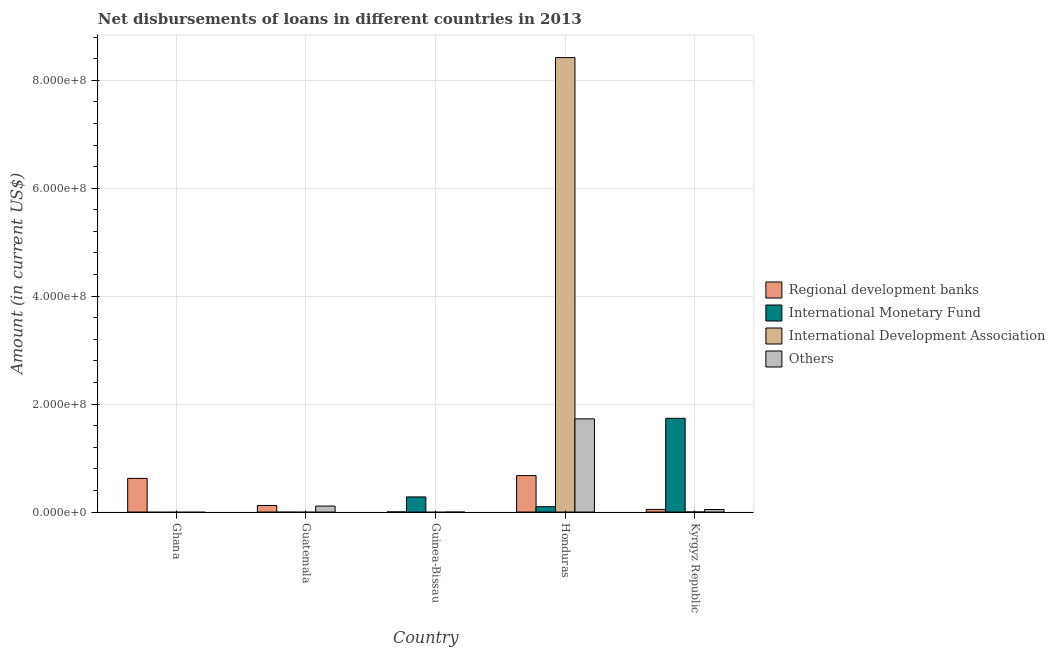Are the number of bars per tick equal to the number of legend labels?
Give a very brief answer. No. Are the number of bars on each tick of the X-axis equal?
Keep it short and to the point. No. How many bars are there on the 2nd tick from the left?
Your answer should be very brief. 2. What is the label of the 3rd group of bars from the left?
Offer a terse response. Guinea-Bissau. What is the amount of loan disimbursed by international development association in Guinea-Bissau?
Offer a very short reply. 0. Across all countries, what is the maximum amount of loan disimbursed by international monetary fund?
Make the answer very short. 1.74e+08. In which country was the amount of loan disimbursed by regional development banks maximum?
Ensure brevity in your answer.  Honduras. What is the total amount of loan disimbursed by international monetary fund in the graph?
Give a very brief answer. 2.12e+08. What is the difference between the amount of loan disimbursed by regional development banks in Guatemala and that in Kyrgyz Republic?
Provide a succinct answer. 7.32e+06. What is the difference between the amount of loan disimbursed by international development association in Kyrgyz Republic and the amount of loan disimbursed by regional development banks in Guatemala?
Make the answer very short. -1.22e+07. What is the average amount of loan disimbursed by regional development banks per country?
Offer a terse response. 2.94e+07. What is the difference between the amount of loan disimbursed by other organisations and amount of loan disimbursed by regional development banks in Honduras?
Keep it short and to the point. 1.05e+08. What is the ratio of the amount of loan disimbursed by regional development banks in Guatemala to that in Guinea-Bissau?
Provide a succinct answer. 59.67. What is the difference between the highest and the second highest amount of loan disimbursed by international monetary fund?
Make the answer very short. 1.46e+08. What is the difference between the highest and the lowest amount of loan disimbursed by other organisations?
Give a very brief answer. 1.73e+08. In how many countries, is the amount of loan disimbursed by international development association greater than the average amount of loan disimbursed by international development association taken over all countries?
Ensure brevity in your answer.  1. Is it the case that in every country, the sum of the amount of loan disimbursed by international monetary fund and amount of loan disimbursed by regional development banks is greater than the sum of amount of loan disimbursed by international development association and amount of loan disimbursed by other organisations?
Offer a terse response. No. Is it the case that in every country, the sum of the amount of loan disimbursed by regional development banks and amount of loan disimbursed by international monetary fund is greater than the amount of loan disimbursed by international development association?
Your answer should be compact. No. How many bars are there?
Ensure brevity in your answer.  12. Are all the bars in the graph horizontal?
Your answer should be very brief. No. What is the difference between two consecutive major ticks on the Y-axis?
Provide a succinct answer. 2.00e+08. Does the graph contain grids?
Your answer should be compact. Yes. What is the title of the graph?
Offer a terse response. Net disbursements of loans in different countries in 2013. What is the label or title of the X-axis?
Offer a terse response. Country. What is the label or title of the Y-axis?
Offer a terse response. Amount (in current US$). What is the Amount (in current US$) of Regional development banks in Ghana?
Your answer should be compact. 6.24e+07. What is the Amount (in current US$) of Regional development banks in Guatemala?
Provide a succinct answer. 1.22e+07. What is the Amount (in current US$) of International Monetary Fund in Guatemala?
Make the answer very short. 0. What is the Amount (in current US$) in International Development Association in Guatemala?
Keep it short and to the point. 0. What is the Amount (in current US$) in Others in Guatemala?
Your answer should be compact. 1.10e+07. What is the Amount (in current US$) of Regional development banks in Guinea-Bissau?
Offer a terse response. 2.04e+05. What is the Amount (in current US$) in International Monetary Fund in Guinea-Bissau?
Make the answer very short. 2.80e+07. What is the Amount (in current US$) of Others in Guinea-Bissau?
Offer a terse response. 0. What is the Amount (in current US$) in Regional development banks in Honduras?
Give a very brief answer. 6.75e+07. What is the Amount (in current US$) of International Monetary Fund in Honduras?
Give a very brief answer. 9.93e+06. What is the Amount (in current US$) of International Development Association in Honduras?
Make the answer very short. 8.42e+08. What is the Amount (in current US$) in Others in Honduras?
Your answer should be very brief. 1.73e+08. What is the Amount (in current US$) of Regional development banks in Kyrgyz Republic?
Offer a very short reply. 4.85e+06. What is the Amount (in current US$) of International Monetary Fund in Kyrgyz Republic?
Offer a very short reply. 1.74e+08. What is the Amount (in current US$) of Others in Kyrgyz Republic?
Ensure brevity in your answer.  4.70e+06. Across all countries, what is the maximum Amount (in current US$) of Regional development banks?
Your answer should be compact. 6.75e+07. Across all countries, what is the maximum Amount (in current US$) in International Monetary Fund?
Keep it short and to the point. 1.74e+08. Across all countries, what is the maximum Amount (in current US$) in International Development Association?
Your answer should be very brief. 8.42e+08. Across all countries, what is the maximum Amount (in current US$) in Others?
Ensure brevity in your answer.  1.73e+08. Across all countries, what is the minimum Amount (in current US$) of Regional development banks?
Offer a very short reply. 2.04e+05. Across all countries, what is the minimum Amount (in current US$) of International Monetary Fund?
Your response must be concise. 0. Across all countries, what is the minimum Amount (in current US$) of Others?
Your answer should be compact. 0. What is the total Amount (in current US$) of Regional development banks in the graph?
Make the answer very short. 1.47e+08. What is the total Amount (in current US$) in International Monetary Fund in the graph?
Keep it short and to the point. 2.12e+08. What is the total Amount (in current US$) of International Development Association in the graph?
Offer a terse response. 8.42e+08. What is the total Amount (in current US$) of Others in the graph?
Keep it short and to the point. 1.88e+08. What is the difference between the Amount (in current US$) in Regional development banks in Ghana and that in Guatemala?
Make the answer very short. 5.02e+07. What is the difference between the Amount (in current US$) in Regional development banks in Ghana and that in Guinea-Bissau?
Provide a succinct answer. 6.22e+07. What is the difference between the Amount (in current US$) in Regional development banks in Ghana and that in Honduras?
Your response must be concise. -5.11e+06. What is the difference between the Amount (in current US$) of Regional development banks in Ghana and that in Kyrgyz Republic?
Provide a succinct answer. 5.75e+07. What is the difference between the Amount (in current US$) of Regional development banks in Guatemala and that in Guinea-Bissau?
Provide a succinct answer. 1.20e+07. What is the difference between the Amount (in current US$) in Regional development banks in Guatemala and that in Honduras?
Offer a very short reply. -5.53e+07. What is the difference between the Amount (in current US$) of Others in Guatemala and that in Honduras?
Your response must be concise. -1.62e+08. What is the difference between the Amount (in current US$) in Regional development banks in Guatemala and that in Kyrgyz Republic?
Offer a terse response. 7.32e+06. What is the difference between the Amount (in current US$) in Others in Guatemala and that in Kyrgyz Republic?
Make the answer very short. 6.34e+06. What is the difference between the Amount (in current US$) in Regional development banks in Guinea-Bissau and that in Honduras?
Provide a short and direct response. -6.73e+07. What is the difference between the Amount (in current US$) of International Monetary Fund in Guinea-Bissau and that in Honduras?
Provide a short and direct response. 1.81e+07. What is the difference between the Amount (in current US$) in Regional development banks in Guinea-Bissau and that in Kyrgyz Republic?
Offer a terse response. -4.64e+06. What is the difference between the Amount (in current US$) of International Monetary Fund in Guinea-Bissau and that in Kyrgyz Republic?
Provide a short and direct response. -1.46e+08. What is the difference between the Amount (in current US$) in Regional development banks in Honduras and that in Kyrgyz Republic?
Make the answer very short. 6.26e+07. What is the difference between the Amount (in current US$) of International Monetary Fund in Honduras and that in Kyrgyz Republic?
Give a very brief answer. -1.64e+08. What is the difference between the Amount (in current US$) in Others in Honduras and that in Kyrgyz Republic?
Your answer should be compact. 1.68e+08. What is the difference between the Amount (in current US$) in Regional development banks in Ghana and the Amount (in current US$) in Others in Guatemala?
Your response must be concise. 5.13e+07. What is the difference between the Amount (in current US$) in Regional development banks in Ghana and the Amount (in current US$) in International Monetary Fund in Guinea-Bissau?
Your response must be concise. 3.44e+07. What is the difference between the Amount (in current US$) in Regional development banks in Ghana and the Amount (in current US$) in International Monetary Fund in Honduras?
Your answer should be very brief. 5.25e+07. What is the difference between the Amount (in current US$) in Regional development banks in Ghana and the Amount (in current US$) in International Development Association in Honduras?
Give a very brief answer. -7.80e+08. What is the difference between the Amount (in current US$) of Regional development banks in Ghana and the Amount (in current US$) of Others in Honduras?
Give a very brief answer. -1.10e+08. What is the difference between the Amount (in current US$) of Regional development banks in Ghana and the Amount (in current US$) of International Monetary Fund in Kyrgyz Republic?
Your response must be concise. -1.11e+08. What is the difference between the Amount (in current US$) in Regional development banks in Ghana and the Amount (in current US$) in Others in Kyrgyz Republic?
Make the answer very short. 5.77e+07. What is the difference between the Amount (in current US$) of Regional development banks in Guatemala and the Amount (in current US$) of International Monetary Fund in Guinea-Bissau?
Offer a very short reply. -1.58e+07. What is the difference between the Amount (in current US$) of Regional development banks in Guatemala and the Amount (in current US$) of International Monetary Fund in Honduras?
Offer a terse response. 2.24e+06. What is the difference between the Amount (in current US$) of Regional development banks in Guatemala and the Amount (in current US$) of International Development Association in Honduras?
Give a very brief answer. -8.30e+08. What is the difference between the Amount (in current US$) in Regional development banks in Guatemala and the Amount (in current US$) in Others in Honduras?
Give a very brief answer. -1.60e+08. What is the difference between the Amount (in current US$) in Regional development banks in Guatemala and the Amount (in current US$) in International Monetary Fund in Kyrgyz Republic?
Your response must be concise. -1.61e+08. What is the difference between the Amount (in current US$) of Regional development banks in Guatemala and the Amount (in current US$) of Others in Kyrgyz Republic?
Keep it short and to the point. 7.47e+06. What is the difference between the Amount (in current US$) of Regional development banks in Guinea-Bissau and the Amount (in current US$) of International Monetary Fund in Honduras?
Offer a terse response. -9.72e+06. What is the difference between the Amount (in current US$) of Regional development banks in Guinea-Bissau and the Amount (in current US$) of International Development Association in Honduras?
Offer a terse response. -8.42e+08. What is the difference between the Amount (in current US$) of Regional development banks in Guinea-Bissau and the Amount (in current US$) of Others in Honduras?
Keep it short and to the point. -1.72e+08. What is the difference between the Amount (in current US$) of International Monetary Fund in Guinea-Bissau and the Amount (in current US$) of International Development Association in Honduras?
Your answer should be compact. -8.14e+08. What is the difference between the Amount (in current US$) in International Monetary Fund in Guinea-Bissau and the Amount (in current US$) in Others in Honduras?
Provide a short and direct response. -1.45e+08. What is the difference between the Amount (in current US$) in Regional development banks in Guinea-Bissau and the Amount (in current US$) in International Monetary Fund in Kyrgyz Republic?
Your response must be concise. -1.73e+08. What is the difference between the Amount (in current US$) in Regional development banks in Guinea-Bissau and the Amount (in current US$) in Others in Kyrgyz Republic?
Offer a very short reply. -4.49e+06. What is the difference between the Amount (in current US$) of International Monetary Fund in Guinea-Bissau and the Amount (in current US$) of Others in Kyrgyz Republic?
Your answer should be compact. 2.33e+07. What is the difference between the Amount (in current US$) in Regional development banks in Honduras and the Amount (in current US$) in International Monetary Fund in Kyrgyz Republic?
Keep it short and to the point. -1.06e+08. What is the difference between the Amount (in current US$) of Regional development banks in Honduras and the Amount (in current US$) of Others in Kyrgyz Republic?
Provide a succinct answer. 6.28e+07. What is the difference between the Amount (in current US$) of International Monetary Fund in Honduras and the Amount (in current US$) of Others in Kyrgyz Republic?
Provide a succinct answer. 5.23e+06. What is the difference between the Amount (in current US$) in International Development Association in Honduras and the Amount (in current US$) in Others in Kyrgyz Republic?
Your answer should be very brief. 8.37e+08. What is the average Amount (in current US$) of Regional development banks per country?
Give a very brief answer. 2.94e+07. What is the average Amount (in current US$) of International Monetary Fund per country?
Give a very brief answer. 4.23e+07. What is the average Amount (in current US$) in International Development Association per country?
Offer a very short reply. 1.68e+08. What is the average Amount (in current US$) in Others per country?
Give a very brief answer. 3.77e+07. What is the difference between the Amount (in current US$) of Regional development banks and Amount (in current US$) of Others in Guatemala?
Your answer should be compact. 1.13e+06. What is the difference between the Amount (in current US$) of Regional development banks and Amount (in current US$) of International Monetary Fund in Guinea-Bissau?
Ensure brevity in your answer.  -2.78e+07. What is the difference between the Amount (in current US$) in Regional development banks and Amount (in current US$) in International Monetary Fund in Honduras?
Your response must be concise. 5.76e+07. What is the difference between the Amount (in current US$) in Regional development banks and Amount (in current US$) in International Development Association in Honduras?
Offer a very short reply. -7.75e+08. What is the difference between the Amount (in current US$) of Regional development banks and Amount (in current US$) of Others in Honduras?
Offer a terse response. -1.05e+08. What is the difference between the Amount (in current US$) in International Monetary Fund and Amount (in current US$) in International Development Association in Honduras?
Keep it short and to the point. -8.32e+08. What is the difference between the Amount (in current US$) of International Monetary Fund and Amount (in current US$) of Others in Honduras?
Keep it short and to the point. -1.63e+08. What is the difference between the Amount (in current US$) in International Development Association and Amount (in current US$) in Others in Honduras?
Ensure brevity in your answer.  6.69e+08. What is the difference between the Amount (in current US$) of Regional development banks and Amount (in current US$) of International Monetary Fund in Kyrgyz Republic?
Your response must be concise. -1.69e+08. What is the difference between the Amount (in current US$) in Regional development banks and Amount (in current US$) in Others in Kyrgyz Republic?
Provide a short and direct response. 1.51e+05. What is the difference between the Amount (in current US$) in International Monetary Fund and Amount (in current US$) in Others in Kyrgyz Republic?
Your answer should be compact. 1.69e+08. What is the ratio of the Amount (in current US$) in Regional development banks in Ghana to that in Guatemala?
Your response must be concise. 5.12. What is the ratio of the Amount (in current US$) of Regional development banks in Ghana to that in Guinea-Bissau?
Offer a terse response. 305.78. What is the ratio of the Amount (in current US$) in Regional development banks in Ghana to that in Honduras?
Provide a short and direct response. 0.92. What is the ratio of the Amount (in current US$) of Regional development banks in Ghana to that in Kyrgyz Republic?
Offer a terse response. 12.86. What is the ratio of the Amount (in current US$) in Regional development banks in Guatemala to that in Guinea-Bissau?
Ensure brevity in your answer.  59.67. What is the ratio of the Amount (in current US$) in Regional development banks in Guatemala to that in Honduras?
Make the answer very short. 0.18. What is the ratio of the Amount (in current US$) of Others in Guatemala to that in Honduras?
Provide a succinct answer. 0.06. What is the ratio of the Amount (in current US$) of Regional development banks in Guatemala to that in Kyrgyz Republic?
Your answer should be very brief. 2.51. What is the ratio of the Amount (in current US$) in Others in Guatemala to that in Kyrgyz Republic?
Provide a succinct answer. 2.35. What is the ratio of the Amount (in current US$) of Regional development banks in Guinea-Bissau to that in Honduras?
Offer a very short reply. 0. What is the ratio of the Amount (in current US$) of International Monetary Fund in Guinea-Bissau to that in Honduras?
Offer a very short reply. 2.82. What is the ratio of the Amount (in current US$) in Regional development banks in Guinea-Bissau to that in Kyrgyz Republic?
Provide a short and direct response. 0.04. What is the ratio of the Amount (in current US$) in International Monetary Fund in Guinea-Bissau to that in Kyrgyz Republic?
Give a very brief answer. 0.16. What is the ratio of the Amount (in current US$) in Regional development banks in Honduras to that in Kyrgyz Republic?
Your answer should be compact. 13.92. What is the ratio of the Amount (in current US$) of International Monetary Fund in Honduras to that in Kyrgyz Republic?
Offer a very short reply. 0.06. What is the ratio of the Amount (in current US$) of Others in Honduras to that in Kyrgyz Republic?
Give a very brief answer. 36.74. What is the difference between the highest and the second highest Amount (in current US$) of Regional development banks?
Offer a very short reply. 5.11e+06. What is the difference between the highest and the second highest Amount (in current US$) of International Monetary Fund?
Provide a succinct answer. 1.46e+08. What is the difference between the highest and the second highest Amount (in current US$) in Others?
Ensure brevity in your answer.  1.62e+08. What is the difference between the highest and the lowest Amount (in current US$) of Regional development banks?
Ensure brevity in your answer.  6.73e+07. What is the difference between the highest and the lowest Amount (in current US$) of International Monetary Fund?
Offer a terse response. 1.74e+08. What is the difference between the highest and the lowest Amount (in current US$) in International Development Association?
Your response must be concise. 8.42e+08. What is the difference between the highest and the lowest Amount (in current US$) of Others?
Offer a very short reply. 1.73e+08. 